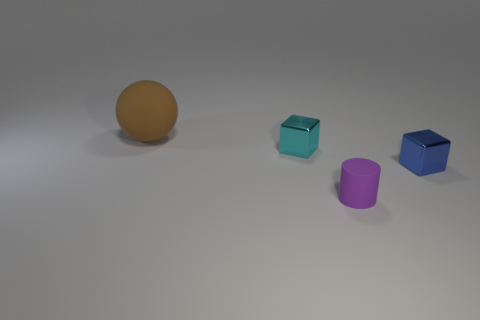What is the color of the thing that is both in front of the cyan shiny block and behind the purple thing?
Ensure brevity in your answer.  Blue. How many big red matte cylinders are there?
Your answer should be very brief. 0. Are there any other things that are the same size as the ball?
Offer a very short reply. No. Does the small cylinder have the same material as the big object?
Offer a very short reply. Yes. There is a matte object behind the small purple thing; does it have the same size as the matte object that is right of the brown matte object?
Provide a short and direct response. No. Is the number of small rubber things less than the number of tiny blue matte spheres?
Offer a terse response. No. How many matte objects are either blue objects or big blocks?
Your answer should be compact. 0. Is there a tiny metal block that is on the right side of the tiny block that is on the right side of the cyan metal thing?
Offer a very short reply. No. Are the tiny object behind the blue metallic block and the purple cylinder made of the same material?
Provide a short and direct response. No. Does the tiny rubber thing have the same color as the big ball?
Your answer should be compact. No. 